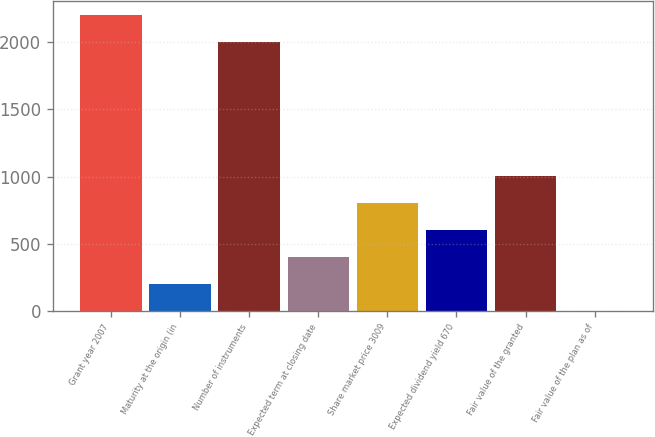Convert chart. <chart><loc_0><loc_0><loc_500><loc_500><bar_chart><fcel>Grant year 2007<fcel>Maturity at the origin (in<fcel>Number of instruments<fcel>Expected term at closing date<fcel>Share market price 3009<fcel>Expected dividend yield 670<fcel>Fair value of the granted<fcel>Fair value of the plan as of<nl><fcel>2200.59<fcel>200.69<fcel>2000<fcel>401.28<fcel>802.46<fcel>601.87<fcel>1003.05<fcel>0.1<nl></chart> 